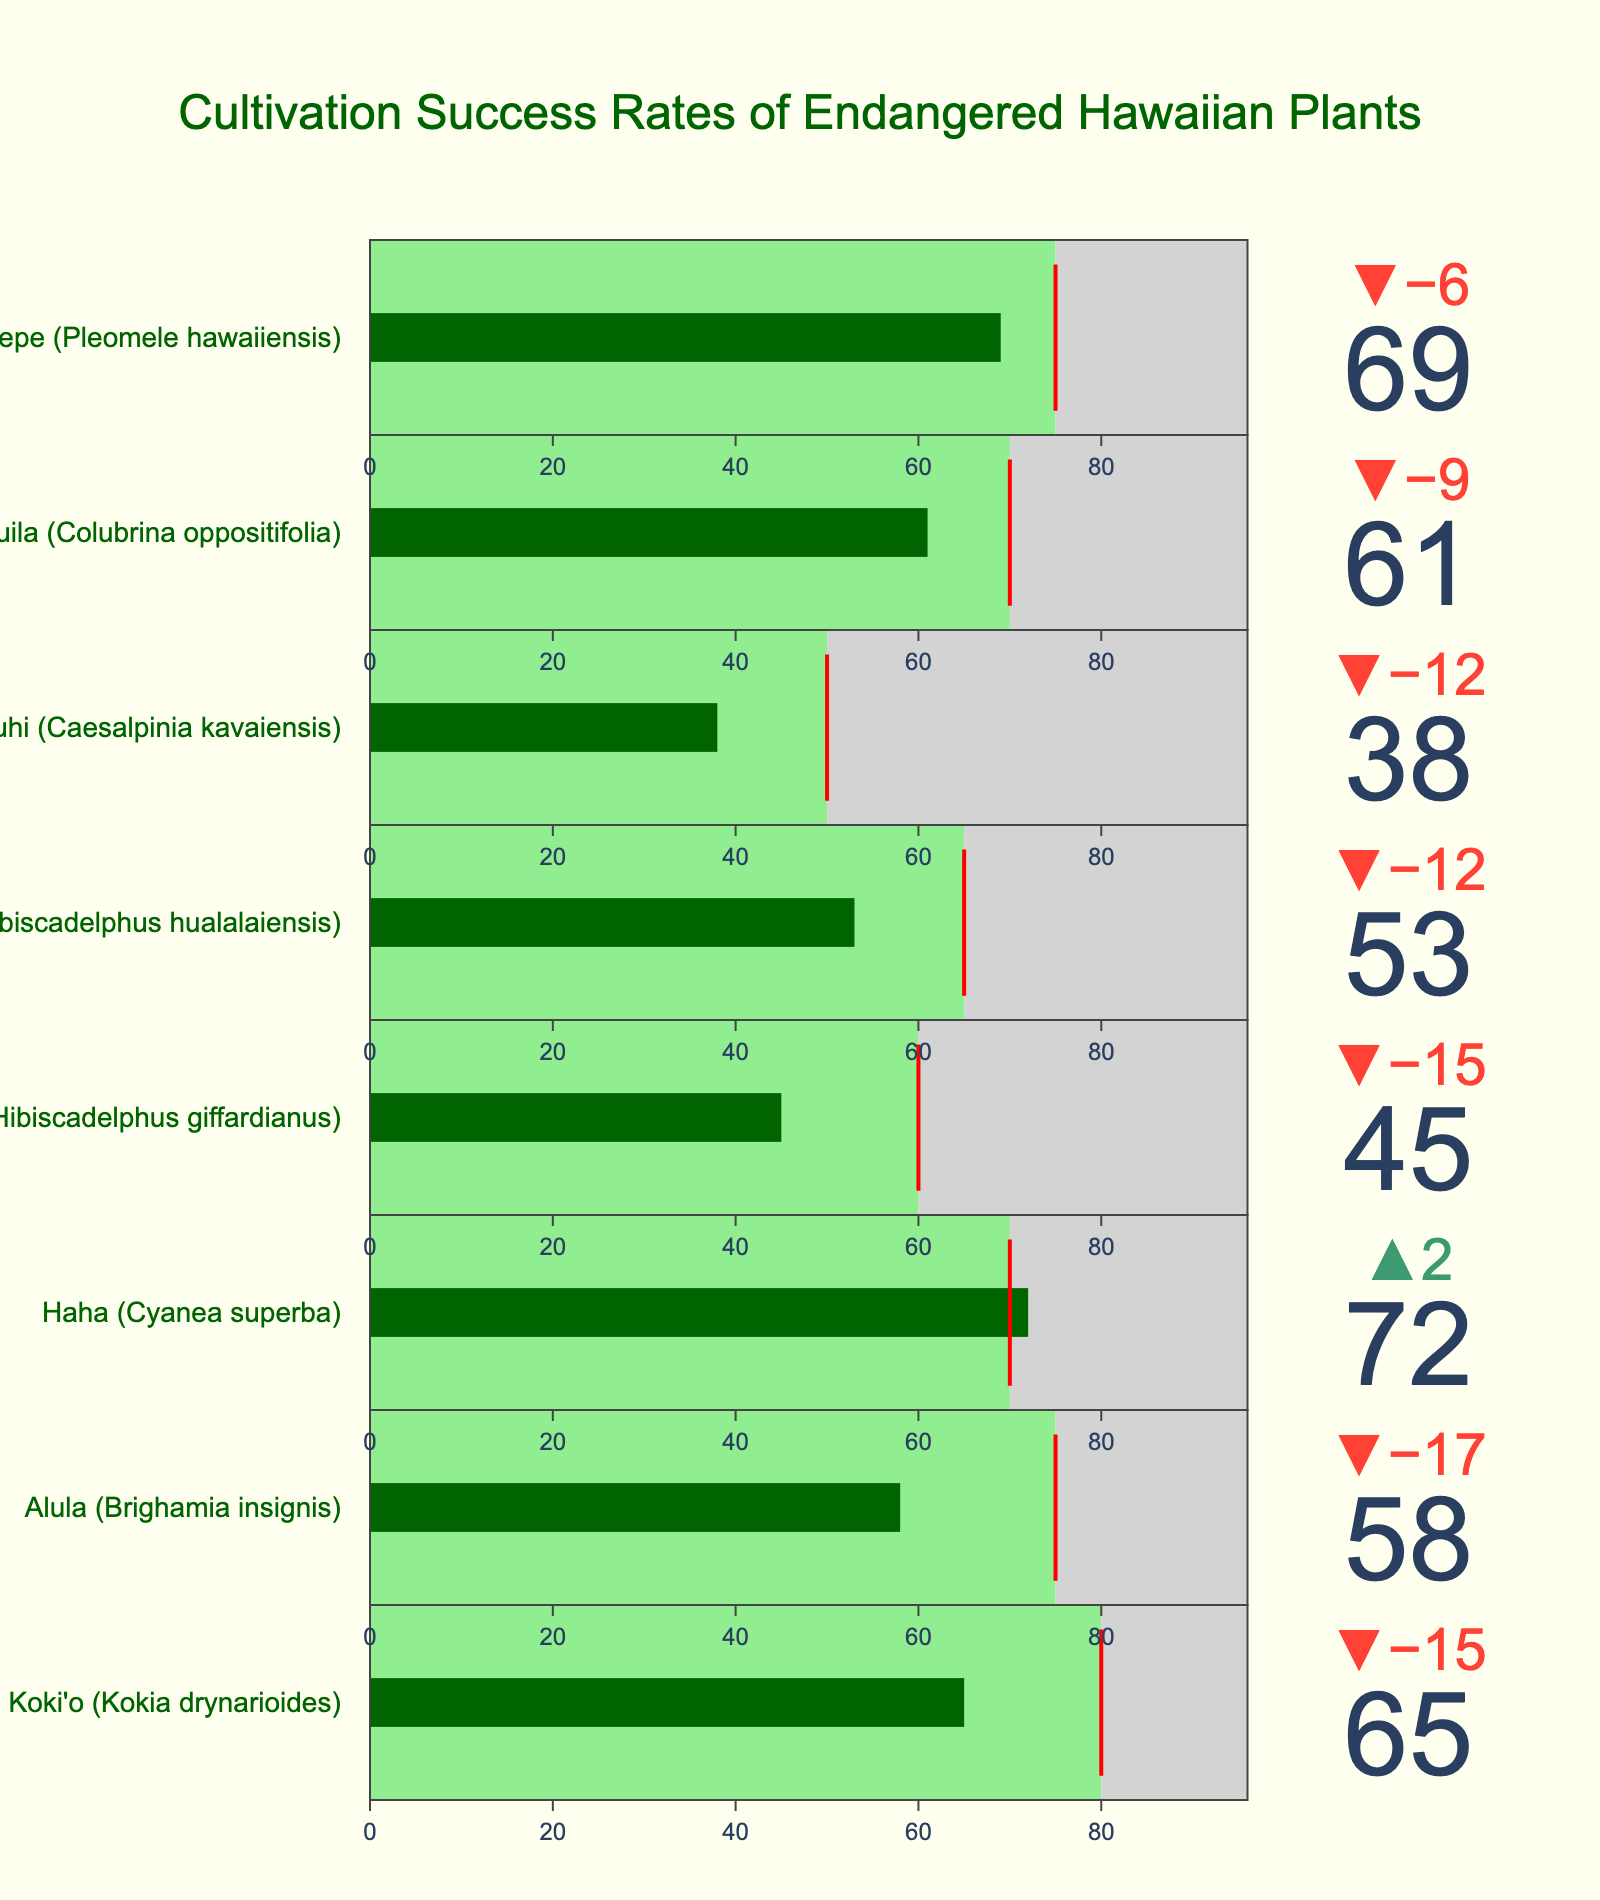What is the title of the figure? The title is usually placed at the top of the figure.
Answer: Cultivation Success Rates of Endangered Hawaiian Plants How many plant species are shown in the figure? Count the number of different plant species listed in the figure.
Answer: 8 Which plant species has the highest actual success rate? Compare the actual success rates of each plant species and identify the largest value.
Answer: Haha (Cyanea superba) Does any plant species meet or exceed its target benchmark? Check if any plant species' actual success rate is equal to or greater than its target benchmark.
Answer: Yes, Haha (Cyanea superba) Which plant species has the lowest actual success rate? Compare the actual success rates of each plant species and identify the smallest value.
Answer: Uhiuhi (Caesalpinia kavaiensis) What is the difference between the target benchmark and actual success rate for Ma'ohauhele (Hibiscadelphus giffardianus)? Find the difference by subtracting the actual success rate from the target benchmark for Ma'ohauhele.
Answer: 15 Which plant species has the greatest difference between its target benchmark and actual success rate? Calculate the difference between the target benchmark and actual success rate for each plant species and identify the largest difference.
Answer: Alula (Brighamia insignis) What is the average actual success rate of all the plant species? Sum all the actual success rates and divide by the number of plant species.
Answer: 57.625 How many plant species have actual success rates greater than 60? Count the number of plant species with actual success rates greater than 60.
Answer: 4 Which plant species has an actual success rate closest to its target benchmark? Calculate the absolute difference between the actual success rate and the target benchmark for each plant species, and find the smallest difference.
Answer: Haha (Cyanea superba) 